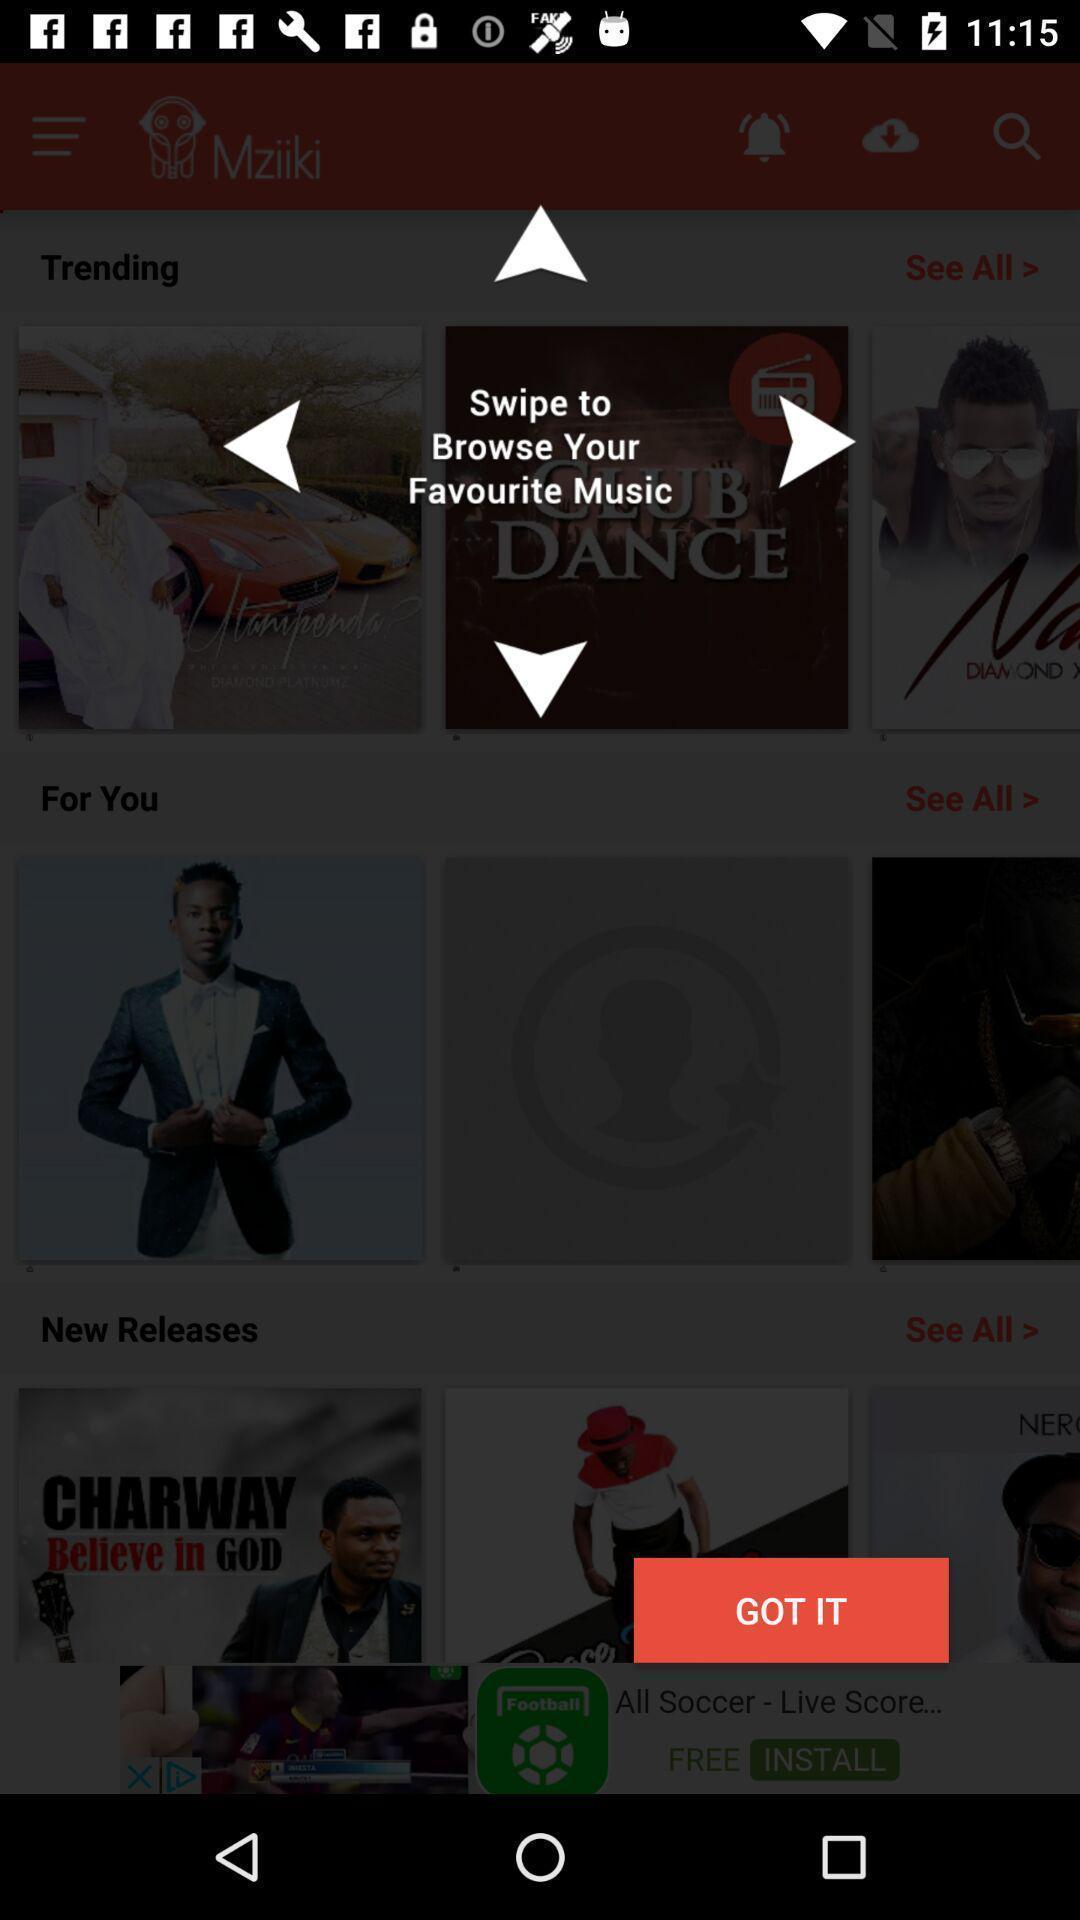Summarize the information in this screenshot. Pop up shows to swipe to browse in music application. 